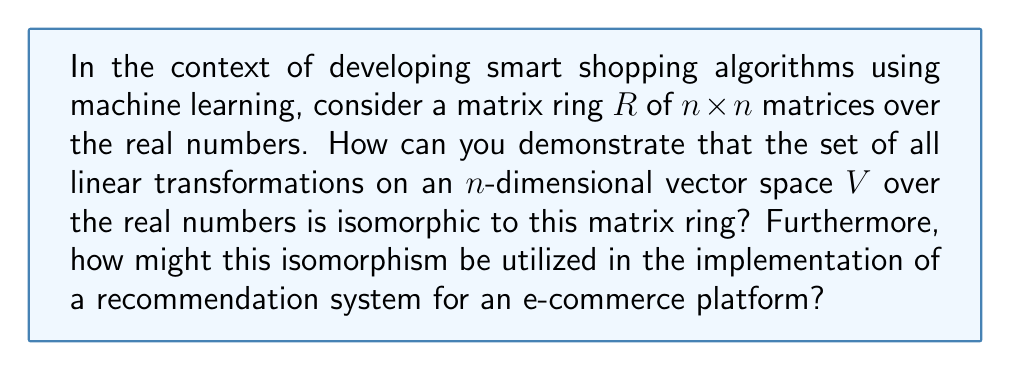Help me with this question. To demonstrate the isomorphism between the matrix ring and the set of linear transformations, we'll follow these steps:

1) First, let's define our structures:
   - $R$: The ring of $n \times n$ matrices over $\mathbb{R}$
   - $L(V)$: The set of all linear transformations on an $n$-dimensional vector space $V$ over $\mathbb{R}$

2) To prove isomorphism, we need to establish a bijective ring homomorphism $\phi: R \to L(V)$.

3) Define $\phi$ as follows: For any matrix $A \in R$, $\phi(A)$ is the linear transformation that maps a vector $v \in V$ to $Av$.

4) To prove this is an isomorphism:
   a) Prove $\phi$ is injective: If $\phi(A) = \phi(B)$, then $Av = Bv$ for all $v \in V$. This implies $A = B$.
   
   b) Prove $\phi$ is surjective: For any linear transformation $T \in L(V)$, we can find a matrix $A$ such that $T(v) = Av$ for all $v \in V$.
   
   c) Prove $\phi$ preserves ring operations:
      - $\phi(A + B) = \phi(A) + \phi(B)$
      - $\phi(AB) = \phi(A) \circ \phi(B)$

5) This isomorphism establishes a one-to-one correspondence between matrices and linear transformations.

In the context of a recommendation system for an e-commerce platform:

6) User preferences and item features can be represented as vectors in the vector space $V$.

7) The recommendation algorithm can be modeled as a linear transformation $T: V \to V$, which maps user preferences to recommended items.

8) By the isomorphism, this transformation can be represented by a matrix $A \in R$.

9) Matrix operations (addition, multiplication) correspond to combining or composing different recommendation strategies.

10) The ring structure allows for more complex algebraic manipulations of these transformations, potentially leading to more sophisticated recommendation algorithms.

This approach allows for efficient computation and manipulation of the recommendation algorithm using well-established matrix operations, while maintaining the theoretical foundation of linear transformations.
Answer: The set of all linear transformations on an $n$-dimensional vector space $V$ over the real numbers is isomorphic to the matrix ring $R$ of $n \times n$ matrices over the real numbers. This isomorphism can be utilized in e-commerce recommendation systems by representing user preferences and item features as vectors, modeling recommendation algorithms as linear transformations (equivalently, matrices), and using matrix operations to efficiently compute and combine different recommendation strategies. 